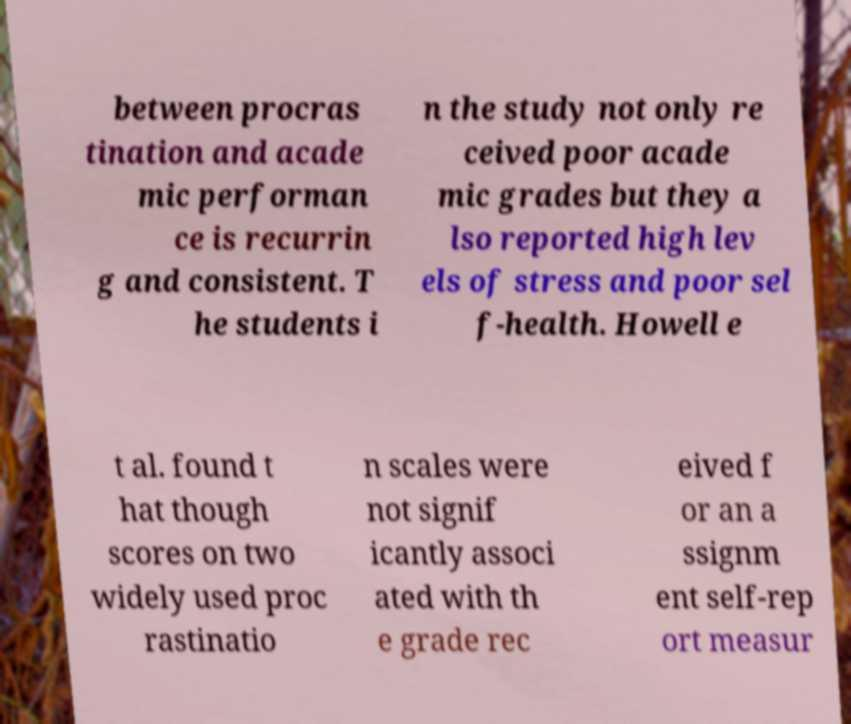I need the written content from this picture converted into text. Can you do that? between procras tination and acade mic performan ce is recurrin g and consistent. T he students i n the study not only re ceived poor acade mic grades but they a lso reported high lev els of stress and poor sel f-health. Howell e t al. found t hat though scores on two widely used proc rastinatio n scales were not signif icantly associ ated with th e grade rec eived f or an a ssignm ent self-rep ort measur 